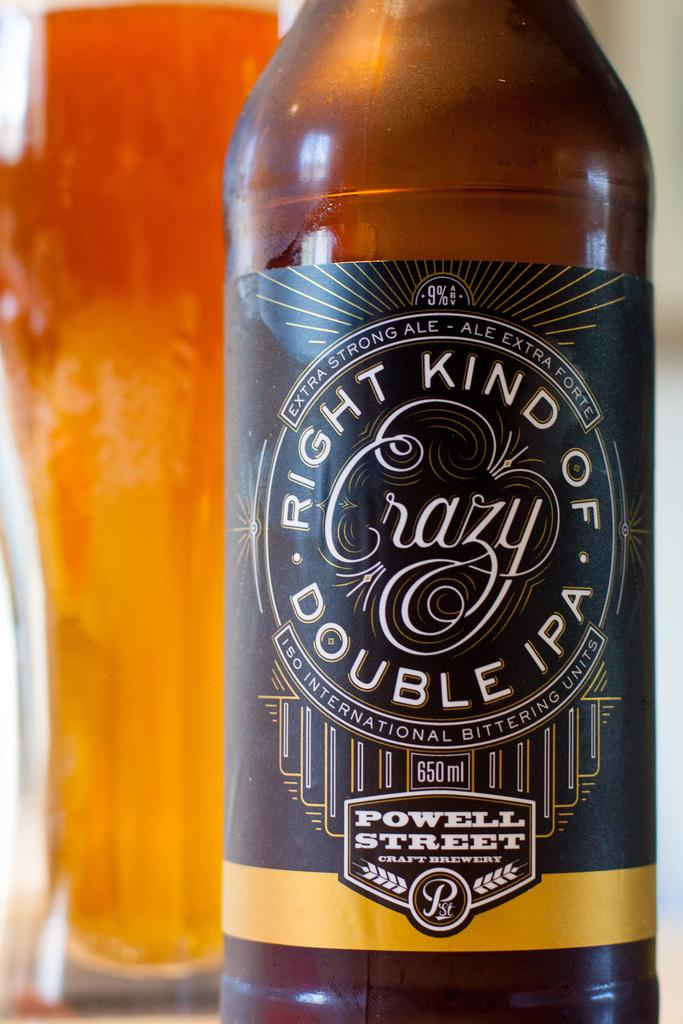<image>
Create a compact narrative representing the image presented. Bottle of Right Kind oF Crazy next to a  full cup of beer. 